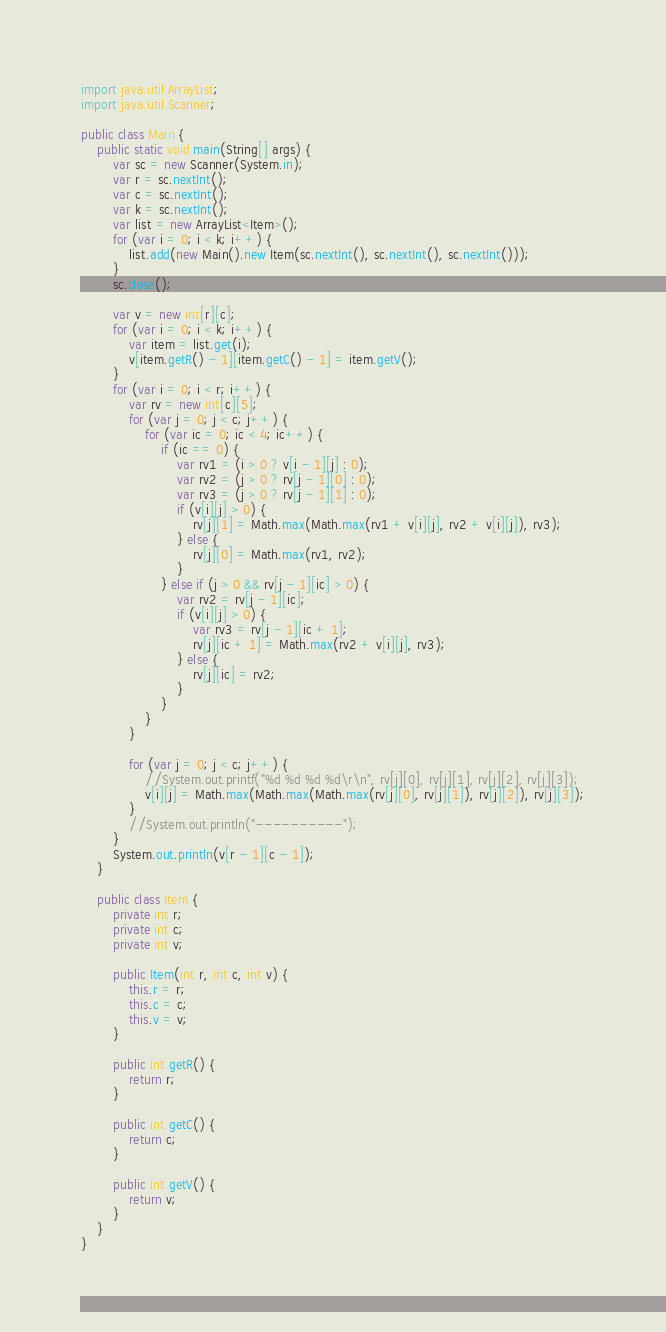<code> <loc_0><loc_0><loc_500><loc_500><_Java_>import java.util.ArrayList;
import java.util.Scanner;

public class Main {
	public static void main(String[] args) {
		var sc = new Scanner(System.in);
		var r = sc.nextInt();
		var c = sc.nextInt();
		var k = sc.nextInt();
		var list = new ArrayList<Item>();
		for (var i = 0; i < k; i++) {
			list.add(new Main().new Item(sc.nextInt(), sc.nextInt(), sc.nextInt()));
		}
		sc.close();

		var v = new int[r][c];
		for (var i = 0; i < k; i++) {
			var item = list.get(i);
			v[item.getR() - 1][item.getC() - 1] = item.getV();
		}
		for (var i = 0; i < r; i++) {
			var rv = new int[c][5];
			for (var j = 0; j < c; j++) {
				for (var ic = 0; ic < 4; ic++) {
					if (ic == 0) {
						var rv1 = (i > 0 ? v[i - 1][j] : 0);
						var rv2 = (j > 0 ? rv[j - 1][0] : 0);
						var rv3 = (j > 0 ? rv[j - 1][1] : 0);
						if (v[i][j] > 0) {
							rv[j][1] = Math.max(Math.max(rv1 + v[i][j], rv2 + v[i][j]), rv3);
						} else {
							rv[j][0] = Math.max(rv1, rv2);
						}
					} else if (j > 0 && rv[j - 1][ic] > 0) {
						var rv2 = rv[j - 1][ic];
						if (v[i][j] > 0) {
							var rv3 = rv[j - 1][ic + 1];
							rv[j][ic + 1] = Math.max(rv2 + v[i][j], rv3);
						} else {
							rv[j][ic] = rv2;
						}
					}
				}
			}

			for (var j = 0; j < c; j++) {
				//System.out.printf("%d %d %d %d\r\n", rv[j][0], rv[j][1], rv[j][2], rv[j][3]);
				v[i][j] = Math.max(Math.max(Math.max(rv[j][0], rv[j][1]), rv[j][2]), rv[j][3]);
			}
			//System.out.println("----------");
		}
		System.out.println(v[r - 1][c - 1]);
	}

	public class Item {
		private int r;
		private int c;
		private int v;

		public Item(int r, int c, int v) {
			this.r = r;
			this.c = c;
			this.v = v;
		}

		public int getR() {
			return r;
		}

		public int getC() {
			return c;
		}

		public int getV() {
			return v;
		}
	}
}
</code> 